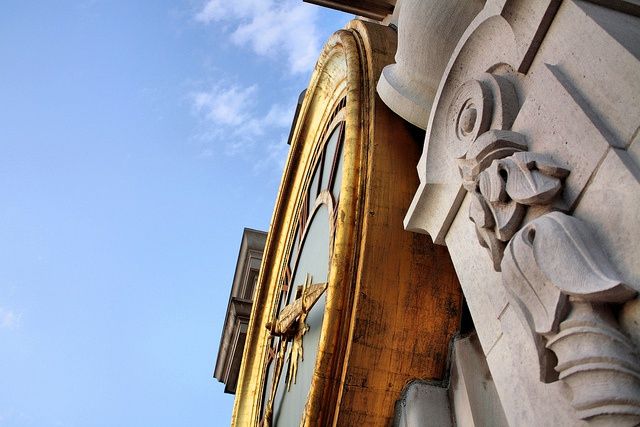Describe the objects in this image and their specific colors. I can see a clock in lightblue, darkgray, black, lightgray, and khaki tones in this image. 